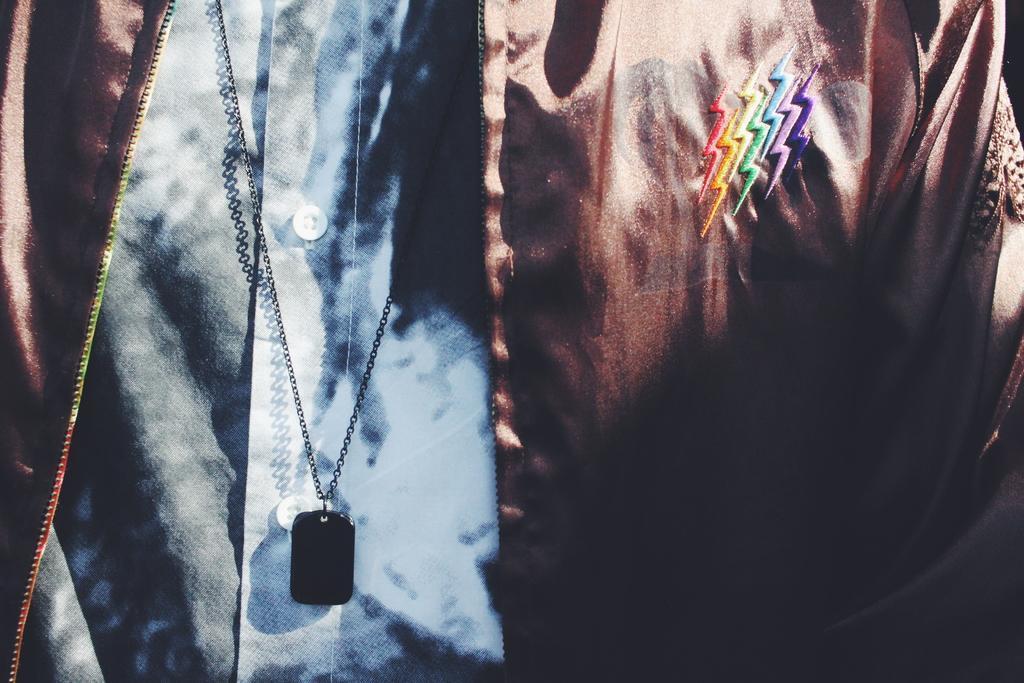Could you give a brief overview of what you see in this image? In this image we can see a person wearing a jacket, shirt and black color chain. 